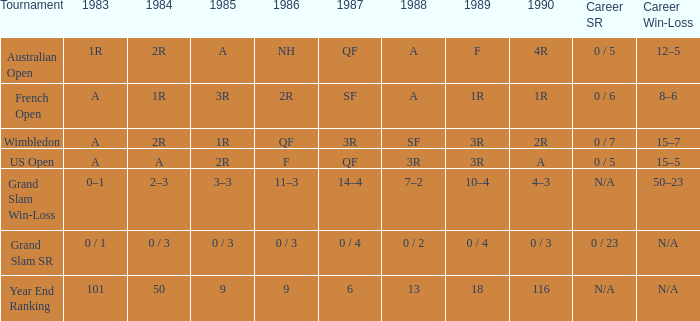In 1983, which event features a 0/1 outcome? Grand Slam SR. Could you parse the entire table as a dict? {'header': ['Tournament', '1983', '1984', '1985', '1986', '1987', '1988', '1989', '1990', 'Career SR', 'Career Win-Loss'], 'rows': [['Australian Open', '1R', '2R', 'A', 'NH', 'QF', 'A', 'F', '4R', '0 / 5', '12–5'], ['French Open', 'A', '1R', '3R', '2R', 'SF', 'A', '1R', '1R', '0 / 6', '8–6'], ['Wimbledon', 'A', '2R', '1R', 'QF', '3R', 'SF', '3R', '2R', '0 / 7', '15–7'], ['US Open', 'A', 'A', '2R', 'F', 'QF', '3R', '3R', 'A', '0 / 5', '15–5'], ['Grand Slam Win-Loss', '0–1', '2–3', '3–3', '11–3', '14–4', '7–2', '10–4', '4–3', 'N/A', '50–23'], ['Grand Slam SR', '0 / 1', '0 / 3', '0 / 3', '0 / 3', '0 / 4', '0 / 2', '0 / 4', '0 / 3', '0 / 23', 'N/A'], ['Year End Ranking', '101', '50', '9', '9', '6', '13', '18', '116', 'N/A', 'N/A']]} 